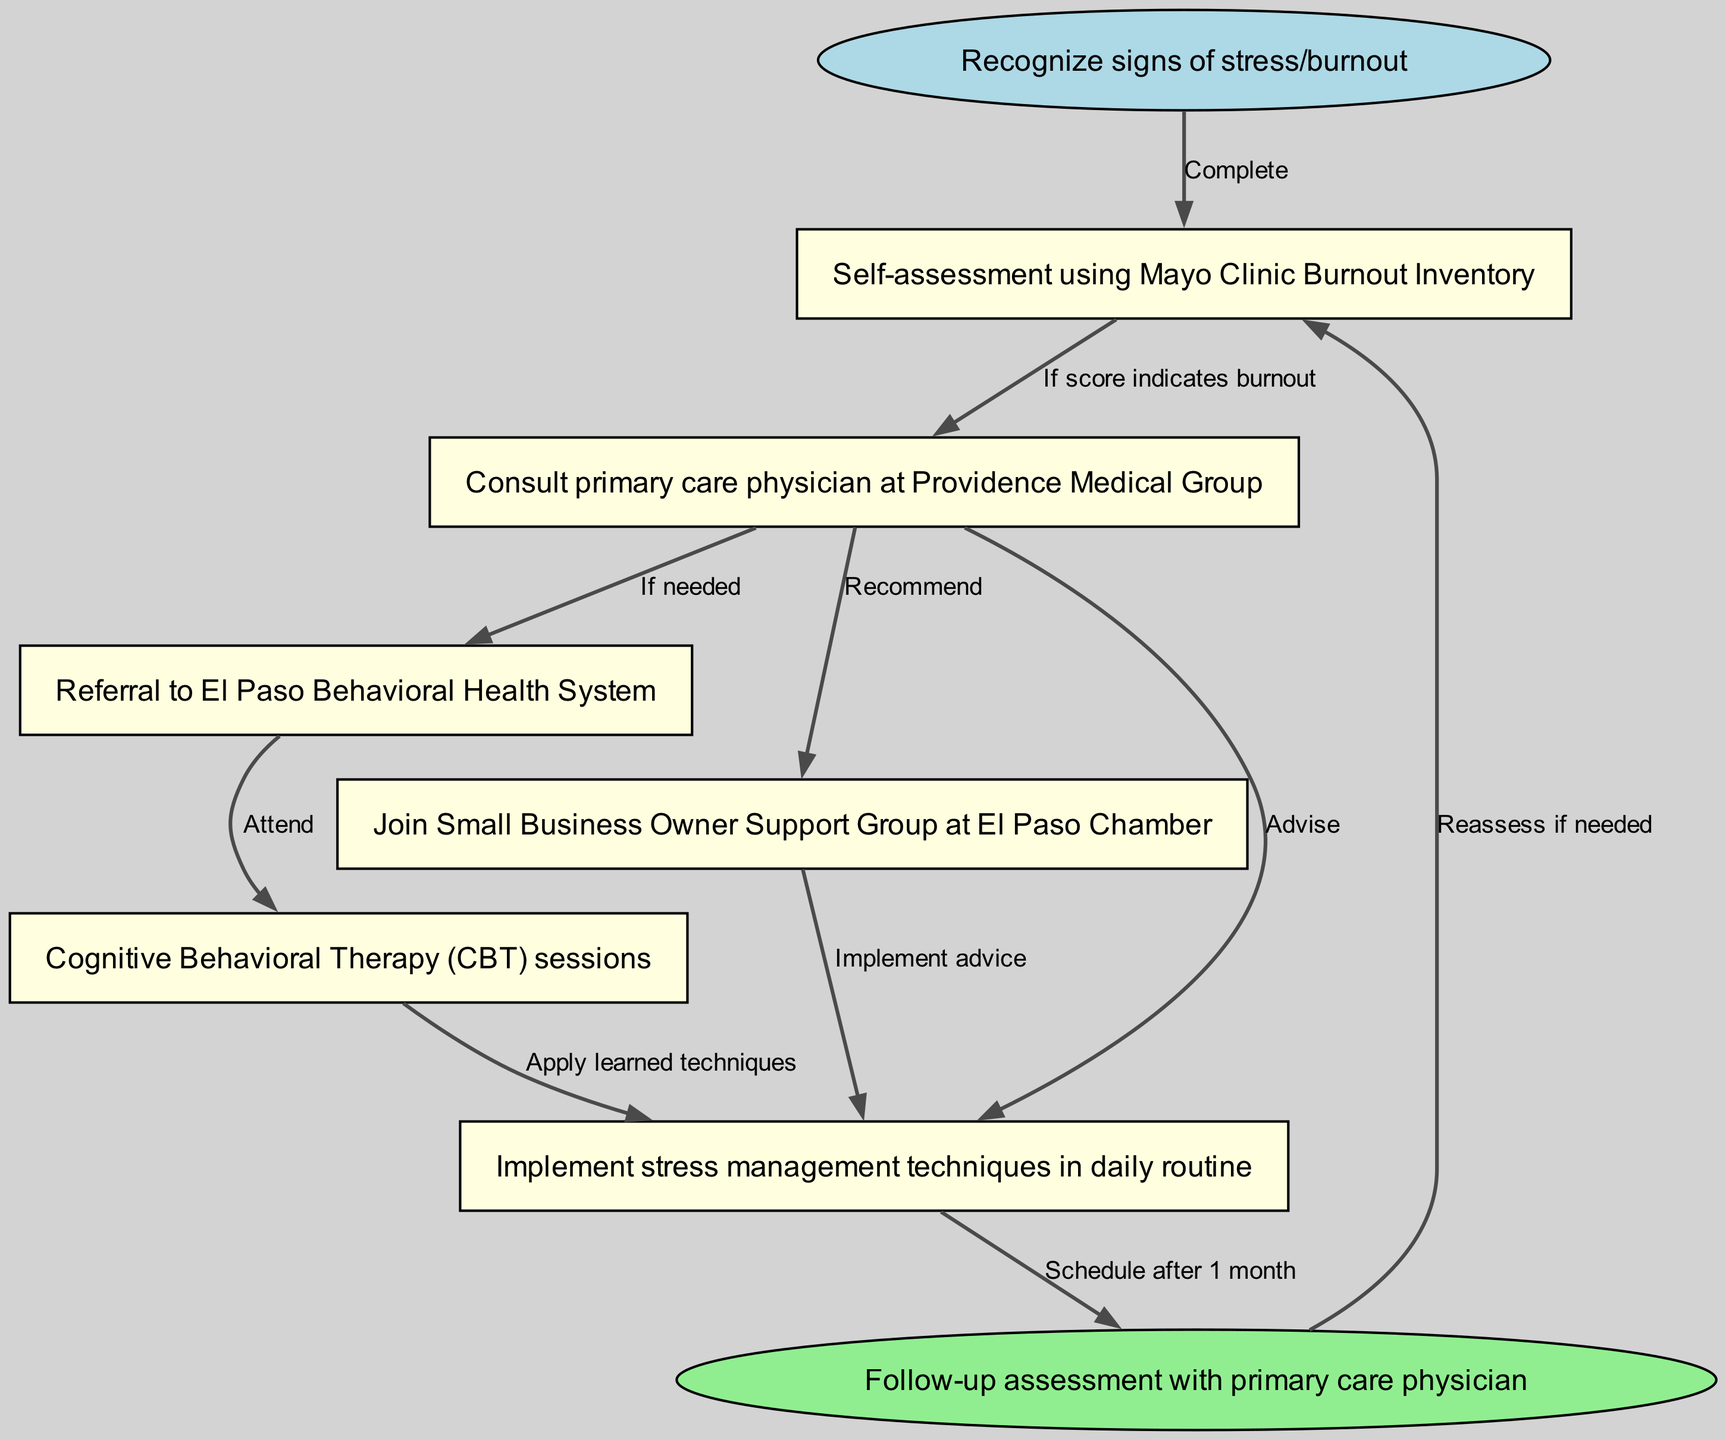What is the first step in the pathway? The first step in the pathway is "Recognize signs of stress/burnout", which is the starting point for identifying issues related to work-related stress and burnout.
Answer: Recognize signs of stress/burnout How many total nodes are in the diagram? The diagram contains a total of eight nodes, which represent different stages or actions in the clinical pathway.
Answer: Eight What is recommended after consulting the primary care physician? After consulting the primary care physician, the recommendations include the option for a referral to the El Paso Behavioral Health System for further assessment and treatment if needed.
Answer: Recommend referral to El Paso Behavioral Health System What do you do if the self-assessment indicates burnout? If the self-assessment indicates burnout, the next step advised is to consult a primary care physician for further evaluation and potential treatment options.
Answer: Consult primary care physician What type of therapy is associated with attending the El Paso Behavioral Health System? The type of therapy associated with attending the El Paso Behavioral Health System is Cognitive Behavioral Therapy (CBT) sessions, which are specifically mentioned as part of the treatment pathway.
Answer: Cognitive Behavioral Therapy (CBT) sessions What is the follow-up action after implementing stress management techniques? The follow-up action after implementing stress management techniques is to schedule a follow-up assessment with the primary care physician after one month to evaluate progress.
Answer: Schedule after one month Which nodes suggest self-management techniques? The nodes that suggest self-management techniques are "Implement stress management techniques in daily routine," which highlights the importance of personal strategies for managing stress and burnout.
Answer: Implement stress management techniques in daily routine What is the flow from CBT sessions back to the self-assessment? The flow from Cognitive Behavioral Therapy (CBT) sessions back to the self-assessment involves applying the learned techniques from therapy and eventually reassessing one's situation after a month, to determine if further intervention is required.
Answer: Reassess if needed 